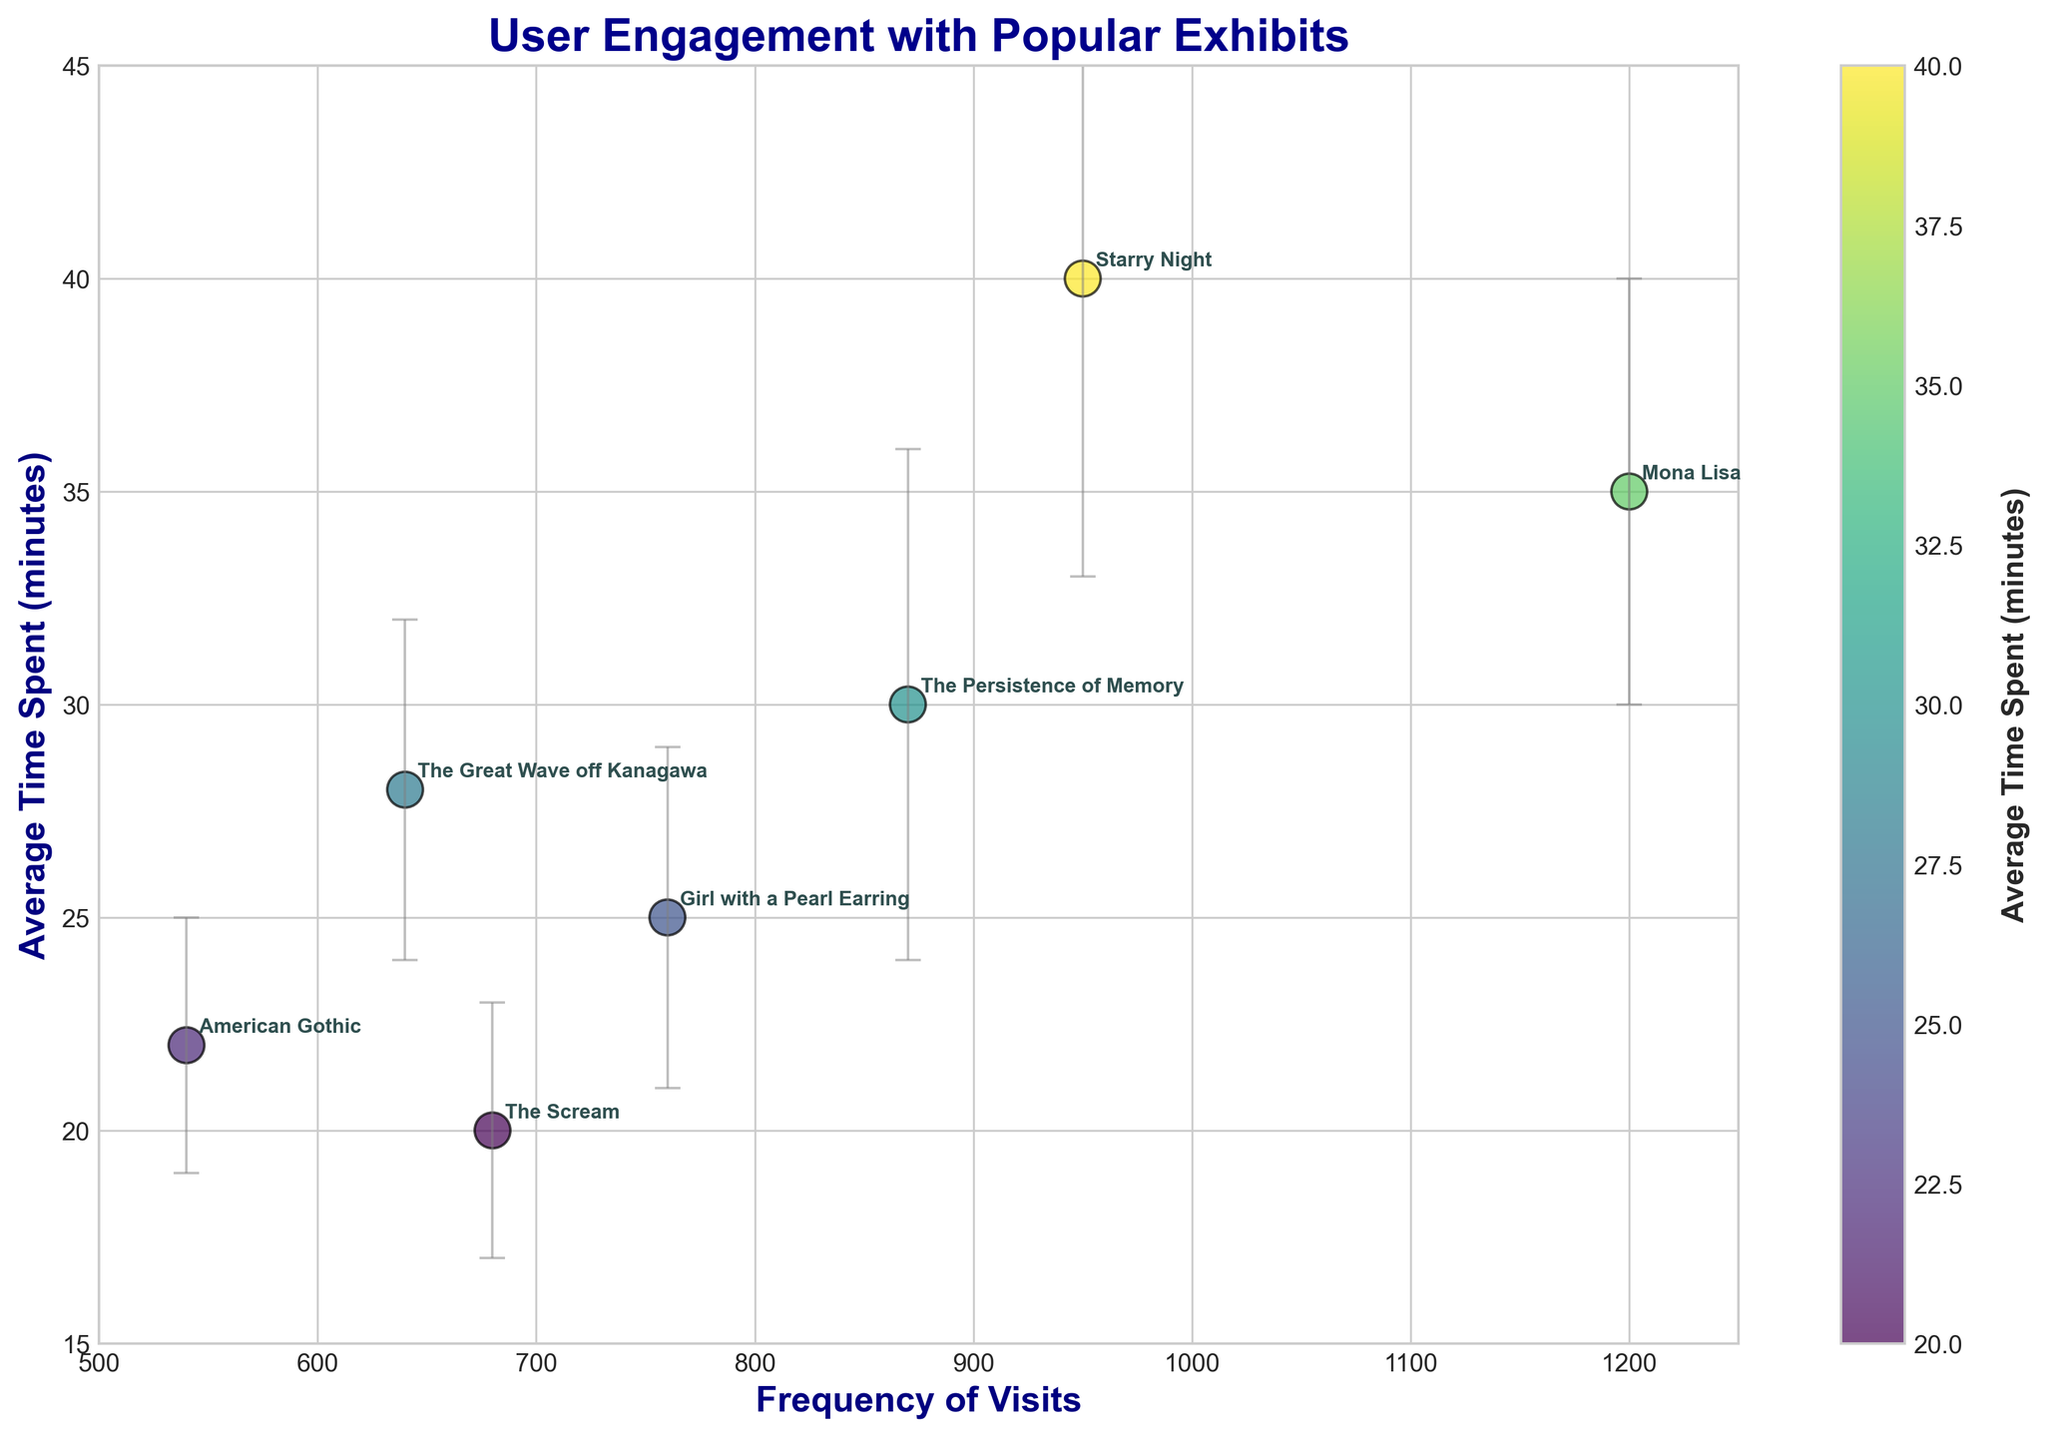What's the title of the figure? The title is displayed at the top of the figure, describing the subject. Here, it reads "User Engagement with Popular Exhibits."
Answer: User Engagement with Popular Exhibits Which exhibit has the highest frequency of visits? The highest data point on the x-axis represents the exhibit with the greatest frequency of visits, which corresponds to the "Mona Lisa."
Answer: Mona Lisa What is the average time spent on "The Persistence of Memory"? Locate "The Persistence of Memory" in the annotations and identify its y-axis value, which shows the average time spent. It's 30 minutes.
Answer: 30 minutes By how many visits does "Starry Night" exceed "Girl with a Pearl Earring"? Find the x-values for both exhibits and subtract the lower value from the higher one: 950 (Starry Night) - 760 (Girl with a Pearl Earring) = 190.
Answer: 190 Which exhibit shows the greatest variation in time spent? The exhibit with the largest error bar in y-axis direction indicates the greatest variability in time spent, shown by the "Starry Night" with a standard deviation of 7 minutes.
Answer: Starry Night Which exhibit has the shortest average time spent? Look for the shortest value on the y-axis, which is for "The Scream" at 20 minutes.
Answer: The Scream How does the average time spent on "American Gothic" compare to "The Great Wave off Kanagawa"? Compare their y-values: "American Gothic" has 22 minutes, while "The Great Wave off Kanagawa" has 28 minutes. "The Great Wave off Kanagawa" has a higher average time spent.
Answer: The Great Wave off Kanagawa has a higher average time spent What is the range of time spent on "Starry Night" considering the standard deviation? To find the range, add and subtract the standard deviation from the average time spent: 40 ± 7 = [33, 47] minutes.
Answer: [33, 47] minutes Approximately how many minutes do users spend between "The Scream" and "Starry Night"? Calculate the difference between the average time spent: 40 minutes (Starry Night) - 20 minutes (The Scream) = 20 minutes.
Answer: 20 minutes 